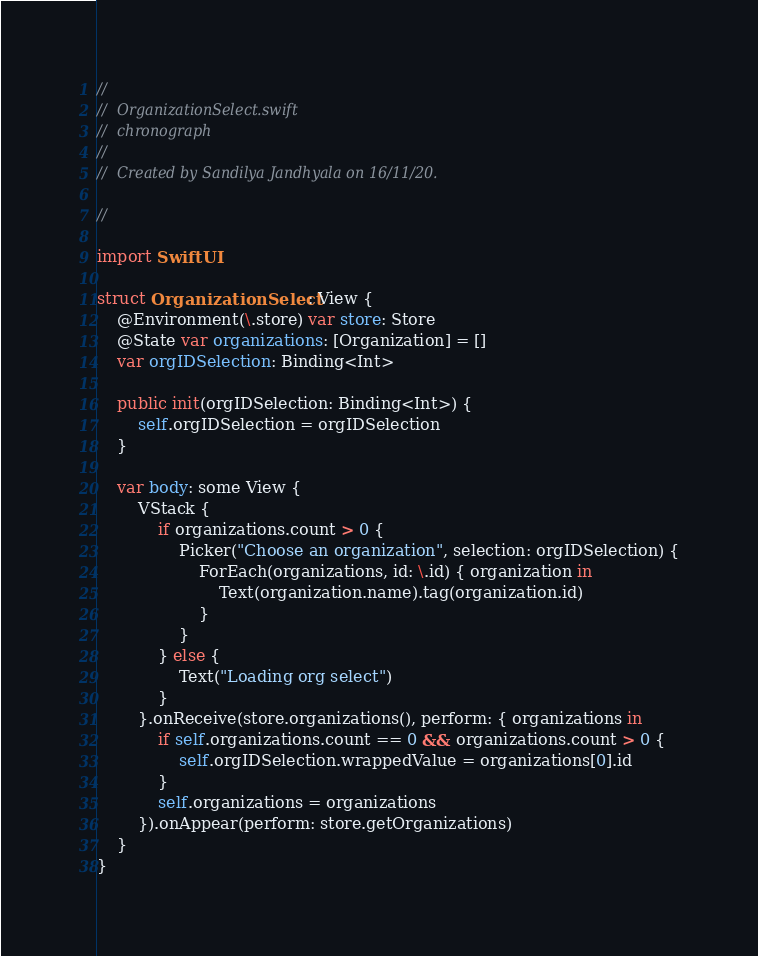<code> <loc_0><loc_0><loc_500><loc_500><_Swift_>//
//  OrganizationSelect.swift
//  chronograph
//
//  Created by Sandilya Jandhyala on 16/11/20.

//

import SwiftUI

struct OrganizationSelect: View {
    @Environment(\.store) var store: Store
    @State var organizations: [Organization] = []
    var orgIDSelection: Binding<Int>
    	
    public init(orgIDSelection: Binding<Int>) {
        self.orgIDSelection = orgIDSelection
    }
    
    var body: some View {
        VStack {
            if organizations.count > 0 {
                Picker("Choose an organization", selection: orgIDSelection) {
                    ForEach(organizations, id: \.id) { organization in
                        Text(organization.name).tag(organization.id)
                    }
                }
            } else {
                Text("Loading org select")
            }
        }.onReceive(store.organizations(), perform: { organizations in
            if self.organizations.count == 0 && organizations.count > 0 {
                self.orgIDSelection.wrappedValue = organizations[0].id
            }
            self.organizations = organizations
        }).onAppear(perform: store.getOrganizations)
    }
}
</code> 